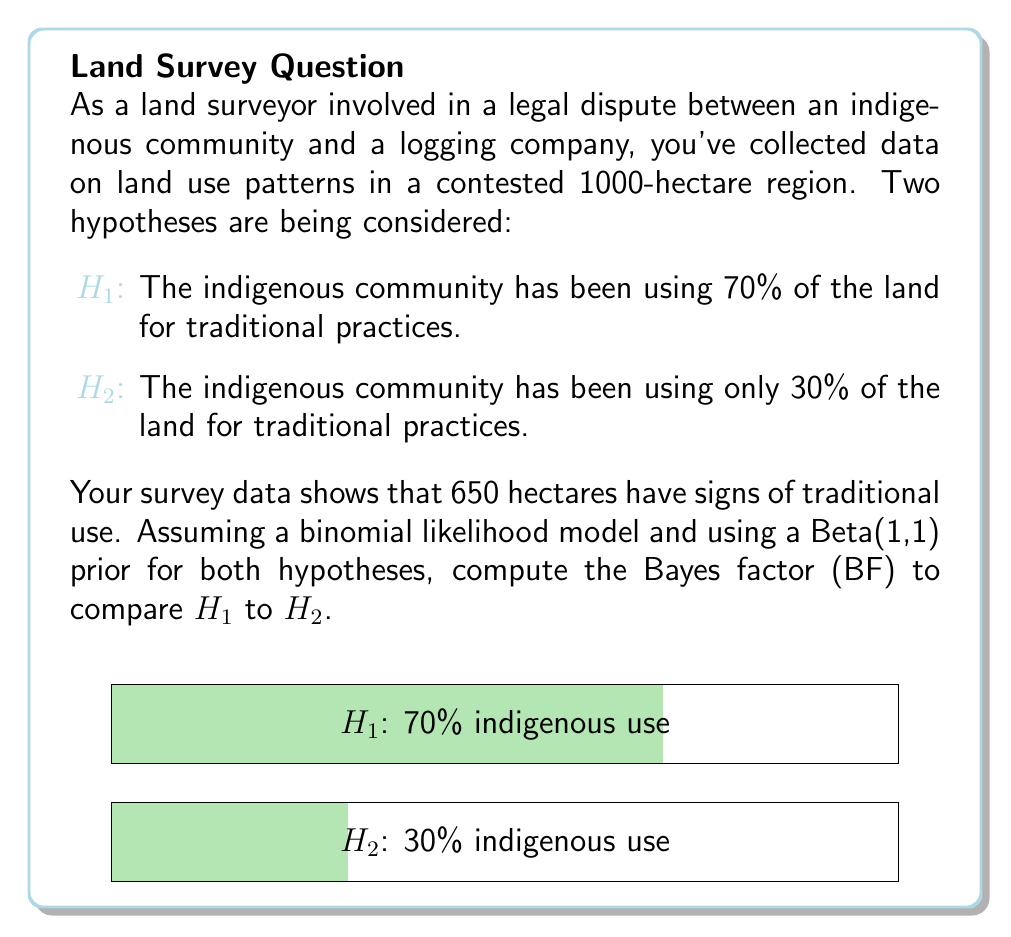Show me your answer to this math problem. To compute the Bayes factor, we need to calculate the marginal likelihoods for both hypotheses and then take their ratio. Let's proceed step-by-step:

1) The likelihood function for a binomial model is:

   $$P(D|\theta) = \binom{n}{k} \theta^k (1-\theta)^{n-k}$$

   where $n = 1000$, $k = 650$, and $\theta$ is the proportion of land used traditionally.

2) For H1, $\theta_1 = 0.7$, and for H2, $\theta_2 = 0.3$.

3) The Beta(1,1) prior is equivalent to a uniform prior on [0,1].

4) The marginal likelihood for each hypothesis is:

   $$P(D|H_i) = \int_0^1 P(D|\theta)P(\theta|H_i)d\theta$$

5) For H1:
   $$P(D|H_1) = \binom{1000}{650} 0.7^{650} (1-0.7)^{350} = 0.0248$$

6) For H2:
   $$P(D|H_2) = \binom{1000}{650} 0.3^{650} (1-0.3)^{350} = 1.26 \times 10^{-98}$$

7) The Bayes factor is the ratio of these marginal likelihoods:

   $$BF_{12} = \frac{P(D|H_1)}{P(D|H_2)} = \frac{0.0248}{1.26 \times 10^{-98}} = 1.97 \times 10^{96}$$

This extremely large Bayes factor strongly favors H1 over H2, providing overwhelming evidence for the indigenous community's claim of using 70% of the land for traditional practices.
Answer: $BF_{12} = 1.97 \times 10^{96}$ 